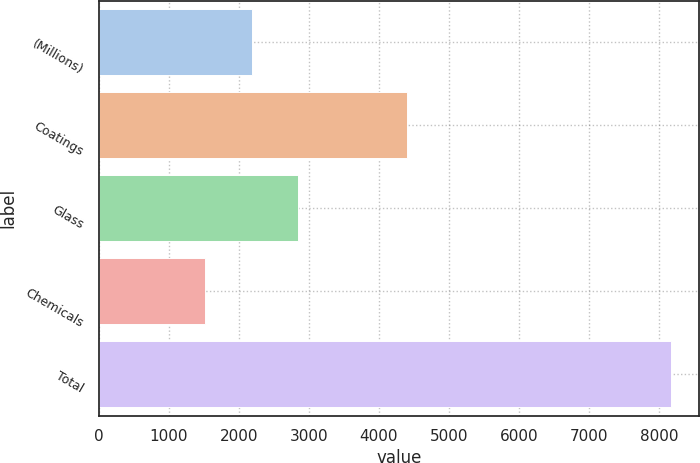Convert chart to OTSL. <chart><loc_0><loc_0><loc_500><loc_500><bar_chart><fcel>(Millions)<fcel>Coatings<fcel>Glass<fcel>Chemicals<fcel>Total<nl><fcel>2187.6<fcel>4410<fcel>2852.2<fcel>1523<fcel>8169<nl></chart> 